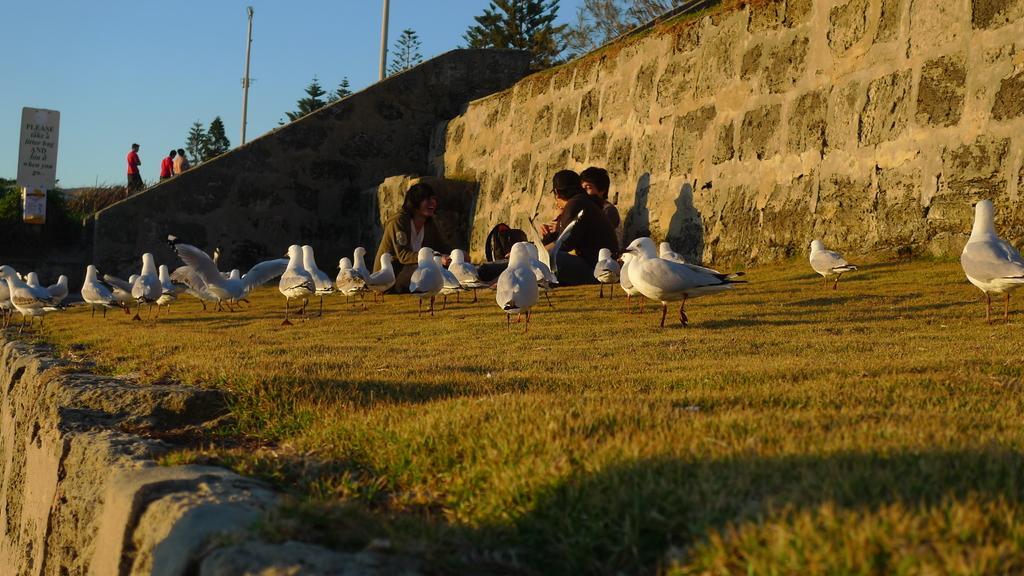Please provide a concise description of this image. In this image I can see the birds which are in white color. These are on the ground. To the side I can see the three people with different color dresses. To the side of people I can see the wall. In the background I can see the board, few more people, poles, many trees and the sky. 